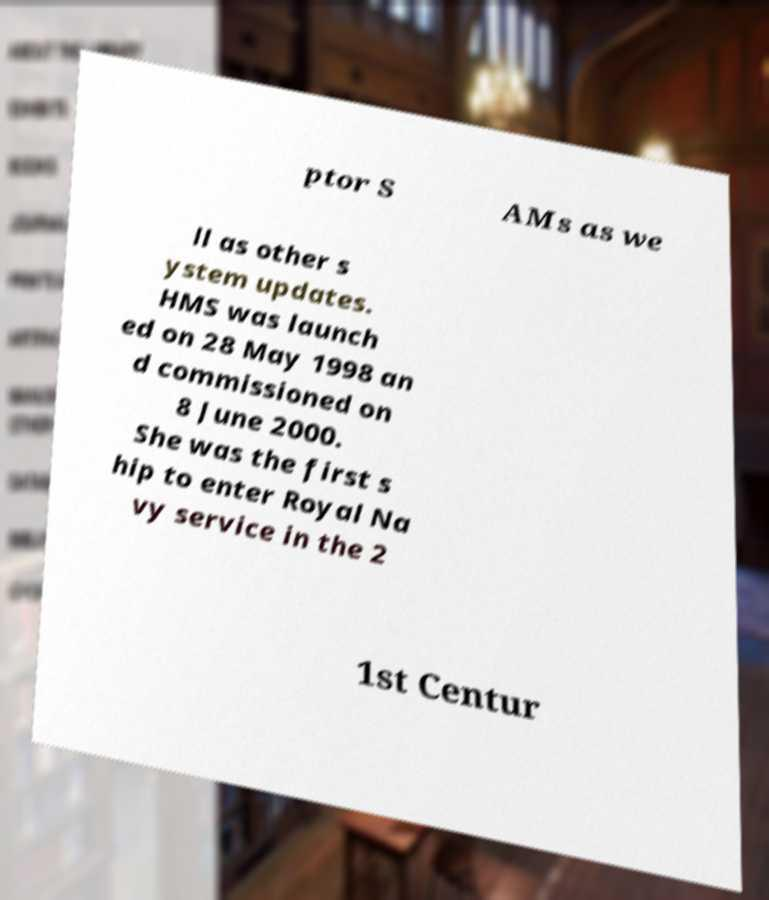Please identify and transcribe the text found in this image. ptor S AMs as we ll as other s ystem updates. HMS was launch ed on 28 May 1998 an d commissioned on 8 June 2000. She was the first s hip to enter Royal Na vy service in the 2 1st Centur 